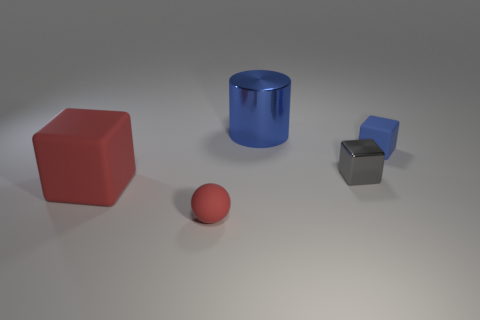What number of other objects are the same material as the tiny ball?
Offer a terse response. 2. There is a blue object on the right side of the blue cylinder; how many small cubes are in front of it?
Provide a short and direct response. 1. How many cylinders are big red rubber things or red objects?
Offer a very short reply. 0. There is a object that is right of the red rubber cube and on the left side of the big blue thing; what is its color?
Ensure brevity in your answer.  Red. Is there any other thing that has the same color as the small matte ball?
Ensure brevity in your answer.  Yes. There is a rubber object in front of the red rubber thing to the left of the sphere; what is its color?
Offer a very short reply. Red. Is the size of the red sphere the same as the blue rubber object?
Provide a short and direct response. Yes. Does the red thing that is left of the ball have the same material as the block that is on the right side of the gray block?
Keep it short and to the point. Yes. There is a red matte thing in front of the big object in front of the thing on the right side of the small metallic object; what shape is it?
Your answer should be compact. Sphere. Is the number of yellow metallic cubes greater than the number of big rubber things?
Provide a succinct answer. No. 